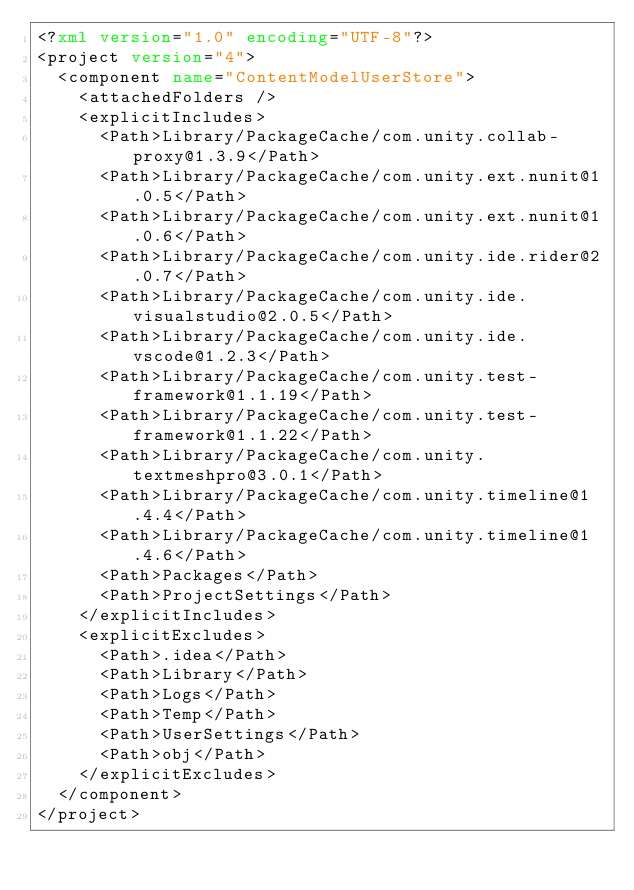Convert code to text. <code><loc_0><loc_0><loc_500><loc_500><_XML_><?xml version="1.0" encoding="UTF-8"?>
<project version="4">
  <component name="ContentModelUserStore">
    <attachedFolders />
    <explicitIncludes>
      <Path>Library/PackageCache/com.unity.collab-proxy@1.3.9</Path>
      <Path>Library/PackageCache/com.unity.ext.nunit@1.0.5</Path>
      <Path>Library/PackageCache/com.unity.ext.nunit@1.0.6</Path>
      <Path>Library/PackageCache/com.unity.ide.rider@2.0.7</Path>
      <Path>Library/PackageCache/com.unity.ide.visualstudio@2.0.5</Path>
      <Path>Library/PackageCache/com.unity.ide.vscode@1.2.3</Path>
      <Path>Library/PackageCache/com.unity.test-framework@1.1.19</Path>
      <Path>Library/PackageCache/com.unity.test-framework@1.1.22</Path>
      <Path>Library/PackageCache/com.unity.textmeshpro@3.0.1</Path>
      <Path>Library/PackageCache/com.unity.timeline@1.4.4</Path>
      <Path>Library/PackageCache/com.unity.timeline@1.4.6</Path>
      <Path>Packages</Path>
      <Path>ProjectSettings</Path>
    </explicitIncludes>
    <explicitExcludes>
      <Path>.idea</Path>
      <Path>Library</Path>
      <Path>Logs</Path>
      <Path>Temp</Path>
      <Path>UserSettings</Path>
      <Path>obj</Path>
    </explicitExcludes>
  </component>
</project></code> 